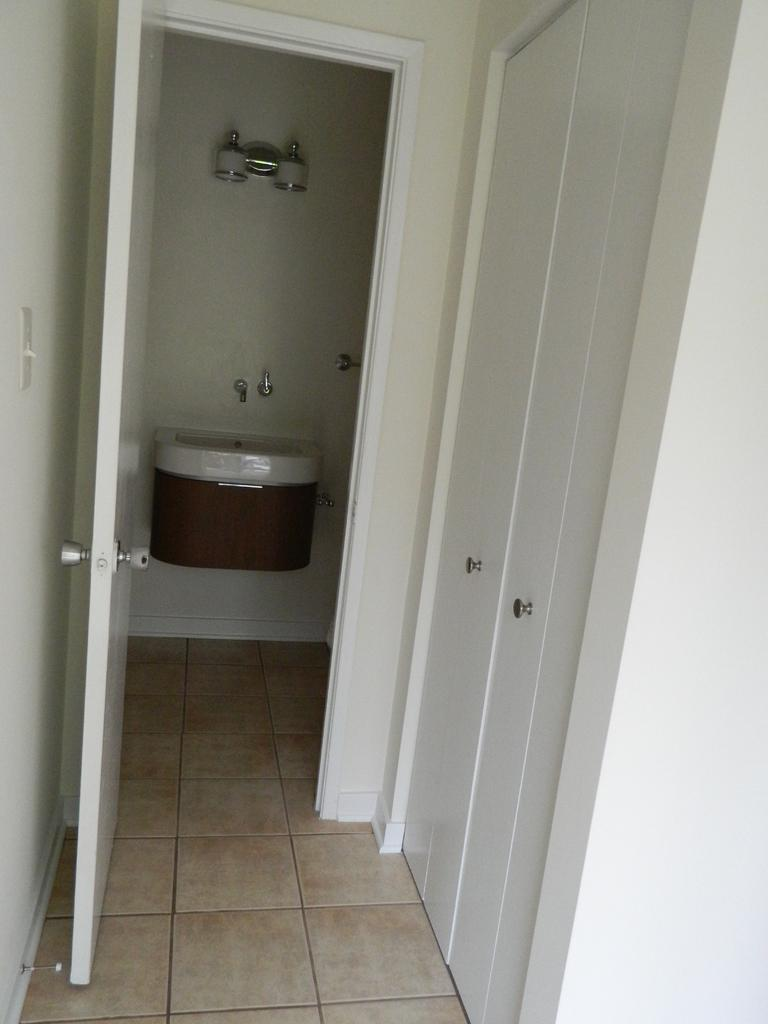What type of structure can be seen in the image? There is a door in the image. What can be found near the door? There is a basin with a tap in the image. What is attached to the wall in the image? There is a wall with a light on it in the image. Can you tell me how many ants are crawling on the door in the image? There are no ants present in the image; it only features a door, basin with a tap, and a wall with a light. Who is the manager of the room in the image? There is no indication of a manager or any people in the image; it only shows a door, basin with a tap, and a wall with a light. 